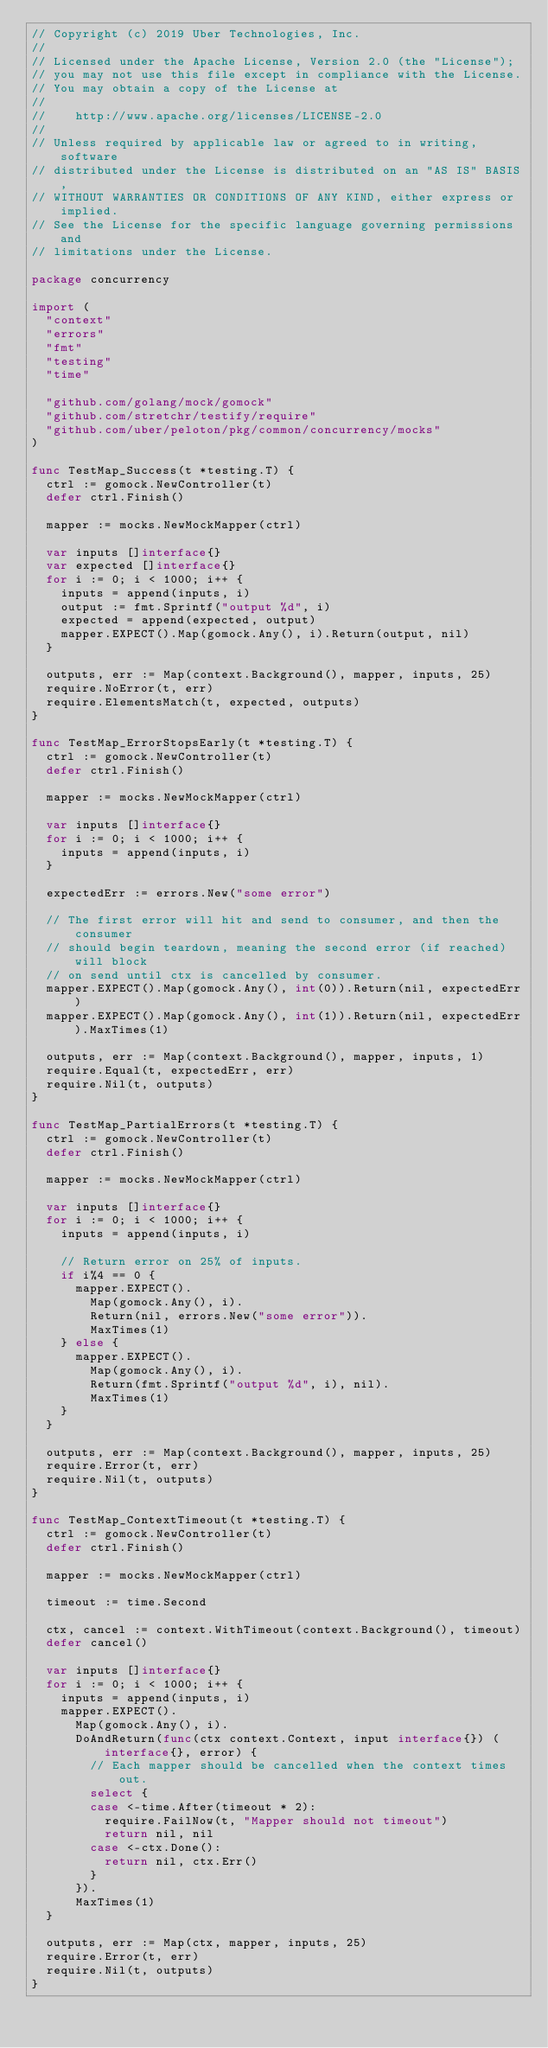<code> <loc_0><loc_0><loc_500><loc_500><_Go_>// Copyright (c) 2019 Uber Technologies, Inc.
//
// Licensed under the Apache License, Version 2.0 (the "License");
// you may not use this file except in compliance with the License.
// You may obtain a copy of the License at
//
//    http://www.apache.org/licenses/LICENSE-2.0
//
// Unless required by applicable law or agreed to in writing, software
// distributed under the License is distributed on an "AS IS" BASIS,
// WITHOUT WARRANTIES OR CONDITIONS OF ANY KIND, either express or implied.
// See the License for the specific language governing permissions and
// limitations under the License.

package concurrency

import (
	"context"
	"errors"
	"fmt"
	"testing"
	"time"

	"github.com/golang/mock/gomock"
	"github.com/stretchr/testify/require"
	"github.com/uber/peloton/pkg/common/concurrency/mocks"
)

func TestMap_Success(t *testing.T) {
	ctrl := gomock.NewController(t)
	defer ctrl.Finish()

	mapper := mocks.NewMockMapper(ctrl)

	var inputs []interface{}
	var expected []interface{}
	for i := 0; i < 1000; i++ {
		inputs = append(inputs, i)
		output := fmt.Sprintf("output %d", i)
		expected = append(expected, output)
		mapper.EXPECT().Map(gomock.Any(), i).Return(output, nil)
	}

	outputs, err := Map(context.Background(), mapper, inputs, 25)
	require.NoError(t, err)
	require.ElementsMatch(t, expected, outputs)
}

func TestMap_ErrorStopsEarly(t *testing.T) {
	ctrl := gomock.NewController(t)
	defer ctrl.Finish()

	mapper := mocks.NewMockMapper(ctrl)

	var inputs []interface{}
	for i := 0; i < 1000; i++ {
		inputs = append(inputs, i)
	}

	expectedErr := errors.New("some error")

	// The first error will hit and send to consumer, and then the consumer
	// should begin teardown, meaning the second error (if reached) will block
	// on send until ctx is cancelled by consumer.
	mapper.EXPECT().Map(gomock.Any(), int(0)).Return(nil, expectedErr)
	mapper.EXPECT().Map(gomock.Any(), int(1)).Return(nil, expectedErr).MaxTimes(1)

	outputs, err := Map(context.Background(), mapper, inputs, 1)
	require.Equal(t, expectedErr, err)
	require.Nil(t, outputs)
}

func TestMap_PartialErrors(t *testing.T) {
	ctrl := gomock.NewController(t)
	defer ctrl.Finish()

	mapper := mocks.NewMockMapper(ctrl)

	var inputs []interface{}
	for i := 0; i < 1000; i++ {
		inputs = append(inputs, i)

		// Return error on 25% of inputs.
		if i%4 == 0 {
			mapper.EXPECT().
				Map(gomock.Any(), i).
				Return(nil, errors.New("some error")).
				MaxTimes(1)
		} else {
			mapper.EXPECT().
				Map(gomock.Any(), i).
				Return(fmt.Sprintf("output %d", i), nil).
				MaxTimes(1)
		}
	}

	outputs, err := Map(context.Background(), mapper, inputs, 25)
	require.Error(t, err)
	require.Nil(t, outputs)
}

func TestMap_ContextTimeout(t *testing.T) {
	ctrl := gomock.NewController(t)
	defer ctrl.Finish()

	mapper := mocks.NewMockMapper(ctrl)

	timeout := time.Second

	ctx, cancel := context.WithTimeout(context.Background(), timeout)
	defer cancel()

	var inputs []interface{}
	for i := 0; i < 1000; i++ {
		inputs = append(inputs, i)
		mapper.EXPECT().
			Map(gomock.Any(), i).
			DoAndReturn(func(ctx context.Context, input interface{}) (interface{}, error) {
				// Each mapper should be cancelled when the context times out.
				select {
				case <-time.After(timeout * 2):
					require.FailNow(t, "Mapper should not timeout")
					return nil, nil
				case <-ctx.Done():
					return nil, ctx.Err()
				}
			}).
			MaxTimes(1)
	}

	outputs, err := Map(ctx, mapper, inputs, 25)
	require.Error(t, err)
	require.Nil(t, outputs)
}
</code> 